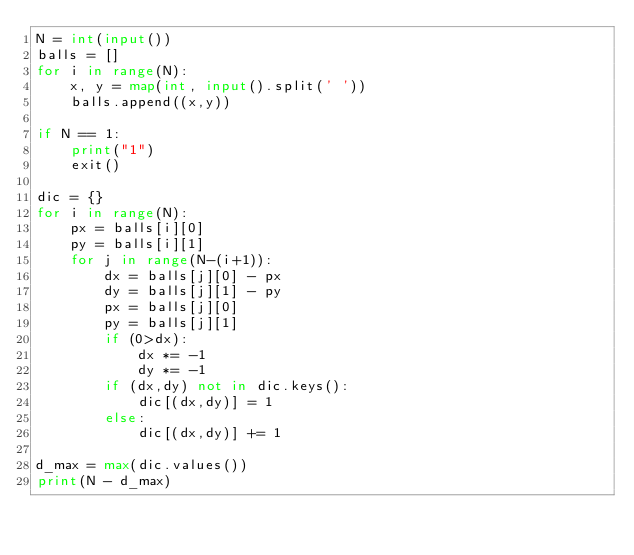Convert code to text. <code><loc_0><loc_0><loc_500><loc_500><_Python_>N = int(input())
balls = []
for i in range(N):
    x, y = map(int, input().split(' '))
    balls.append((x,y))

if N == 1:
    print("1")
    exit()

dic = {}
for i in range(N):
    px = balls[i][0]
    py = balls[i][1]
    for j in range(N-(i+1)):
        dx = balls[j][0] - px
        dy = balls[j][1] - py
        px = balls[j][0]
        py = balls[j][1]
        if (0>dx):
            dx *= -1
            dy *= -1
        if (dx,dy) not in dic.keys():
            dic[(dx,dy)] = 1
        else:
            dic[(dx,dy)] += 1

d_max = max(dic.values())
print(N - d_max)

</code> 